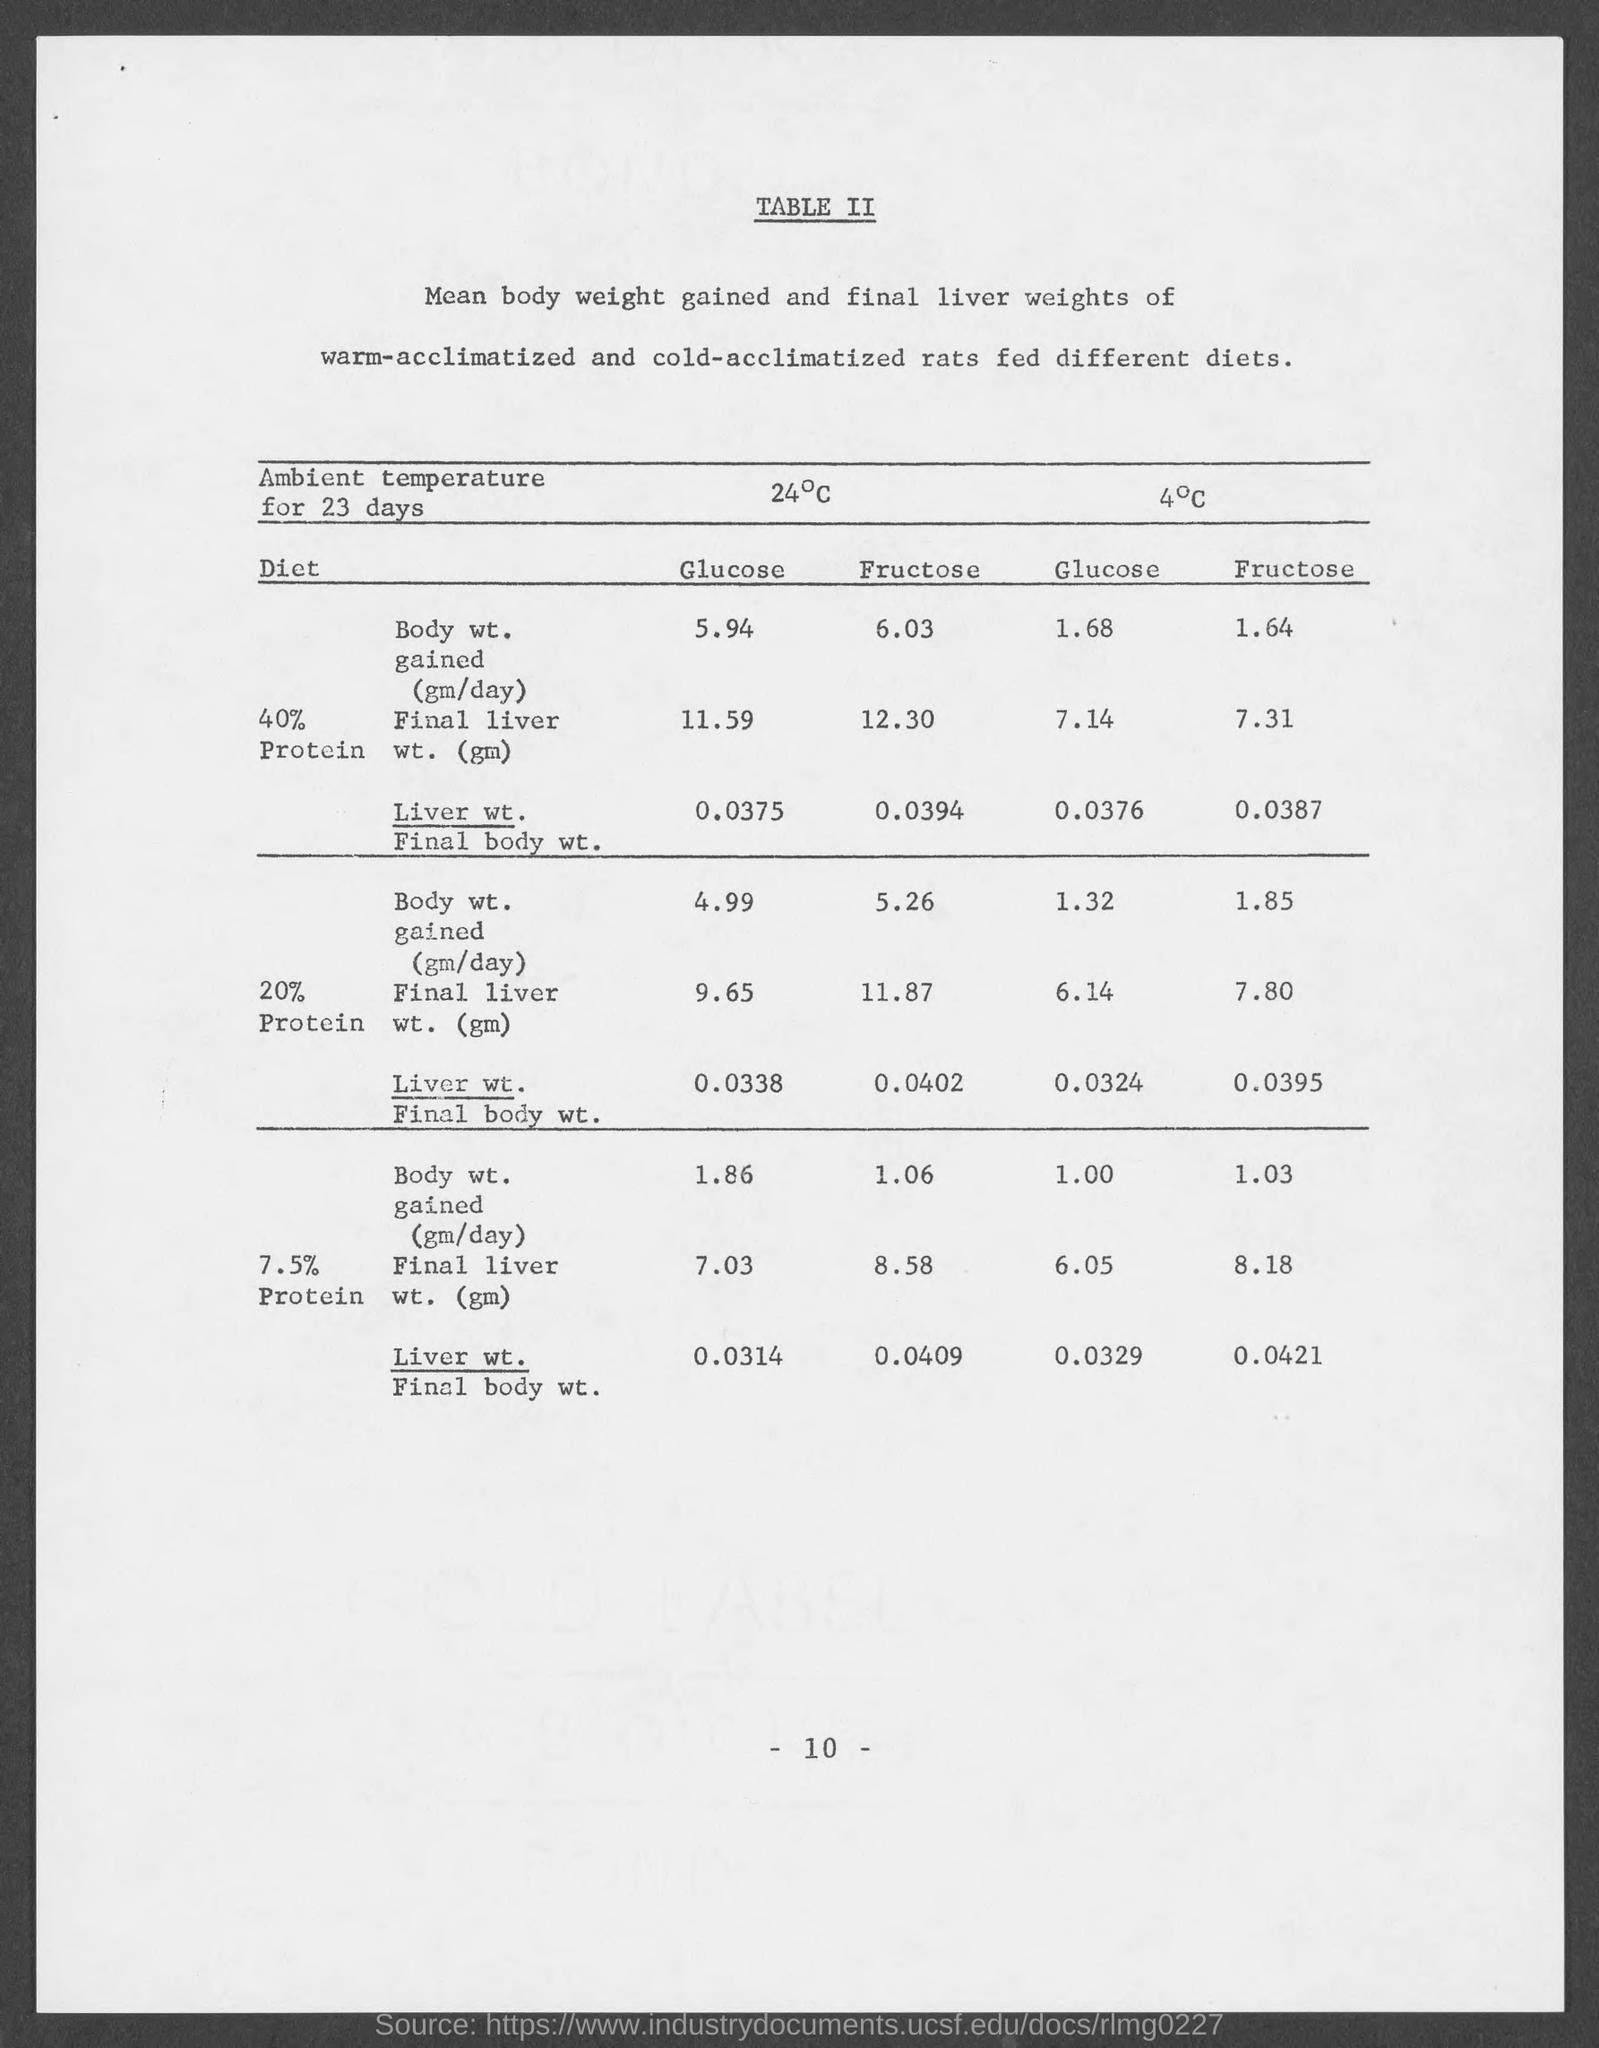Point out several critical features in this image. The page number at the bottom of the page is 10. 